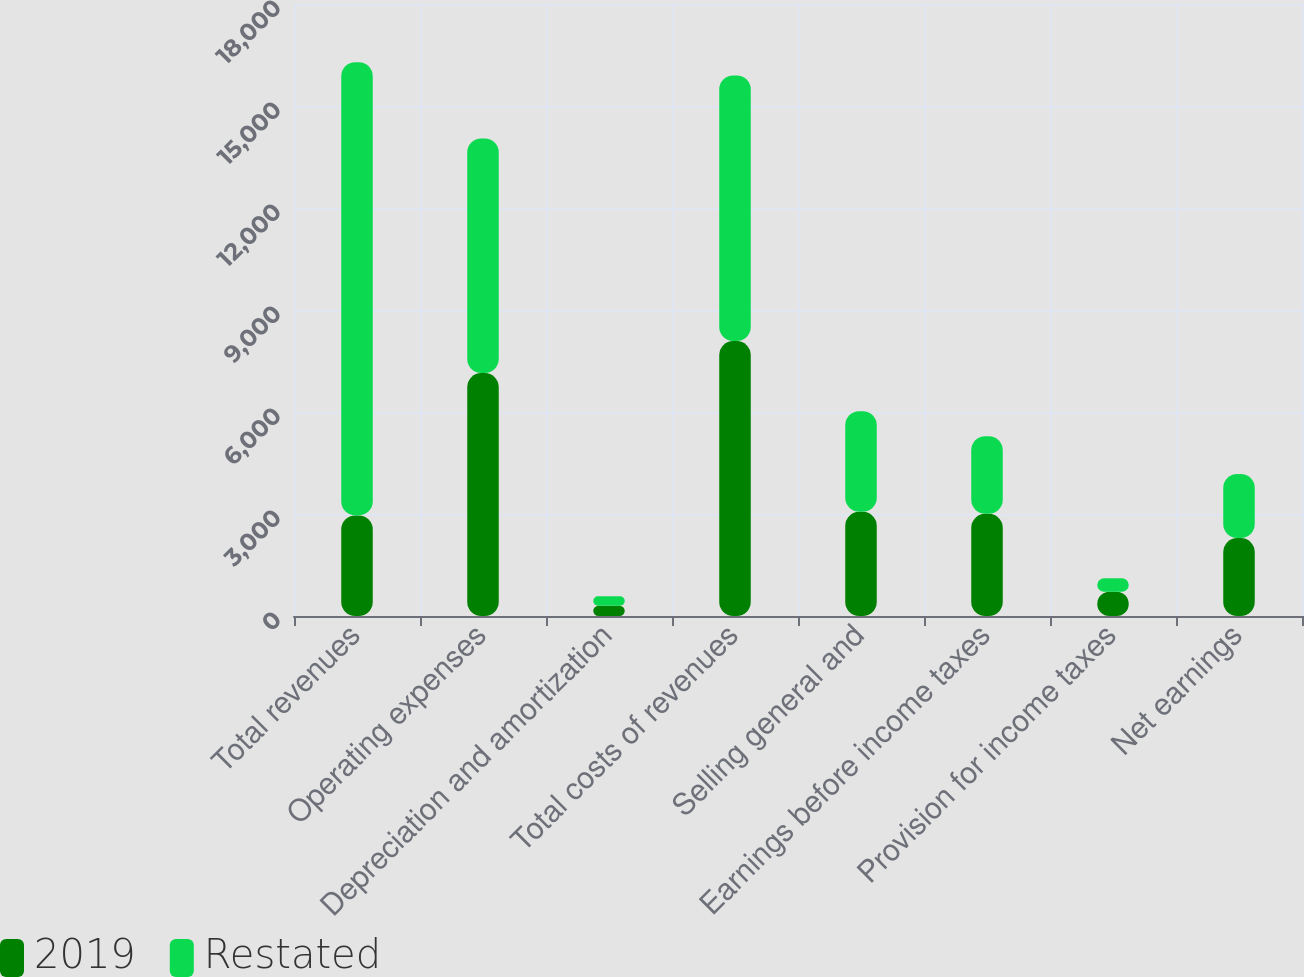Convert chart. <chart><loc_0><loc_0><loc_500><loc_500><stacked_bar_chart><ecel><fcel>Total revenues<fcel>Operating expenses<fcel>Depreciation and amortization<fcel>Total costs of revenues<fcel>Selling general and<fcel>Earnings before income taxes<fcel>Provision for income taxes<fcel>Net earnings<nl><fcel>2019<fcel>2959.4<fcel>7145.9<fcel>304.4<fcel>8086.6<fcel>3064.2<fcel>3005.6<fcel>712.8<fcel>2292.8<nl><fcel>Restated<fcel>13327.7<fcel>6901<fcel>274.5<fcel>7810.9<fcel>2959.4<fcel>2282.6<fcel>397.7<fcel>1884.9<nl></chart> 